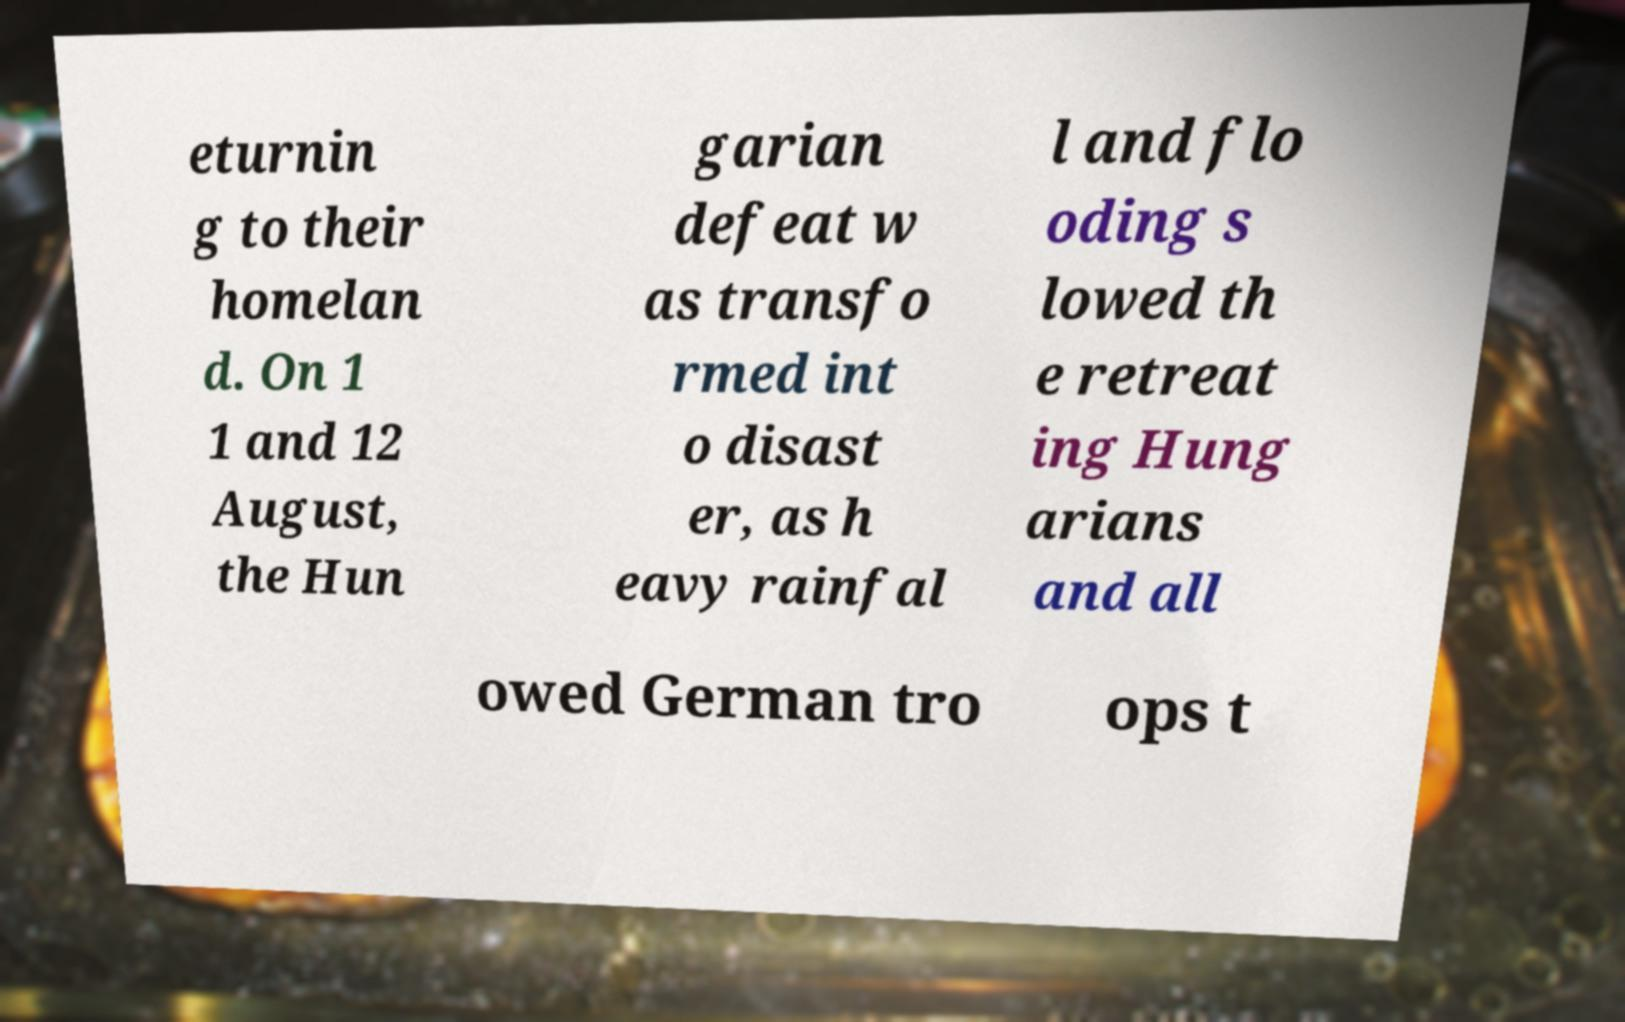Please identify and transcribe the text found in this image. eturnin g to their homelan d. On 1 1 and 12 August, the Hun garian defeat w as transfo rmed int o disast er, as h eavy rainfal l and flo oding s lowed th e retreat ing Hung arians and all owed German tro ops t 